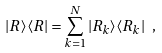Convert formula to latex. <formula><loc_0><loc_0><loc_500><loc_500>| R \rangle \langle R | = \sum _ { k = 1 } ^ { N } | R _ { k } \rangle \langle R _ { k } | \ ,</formula> 